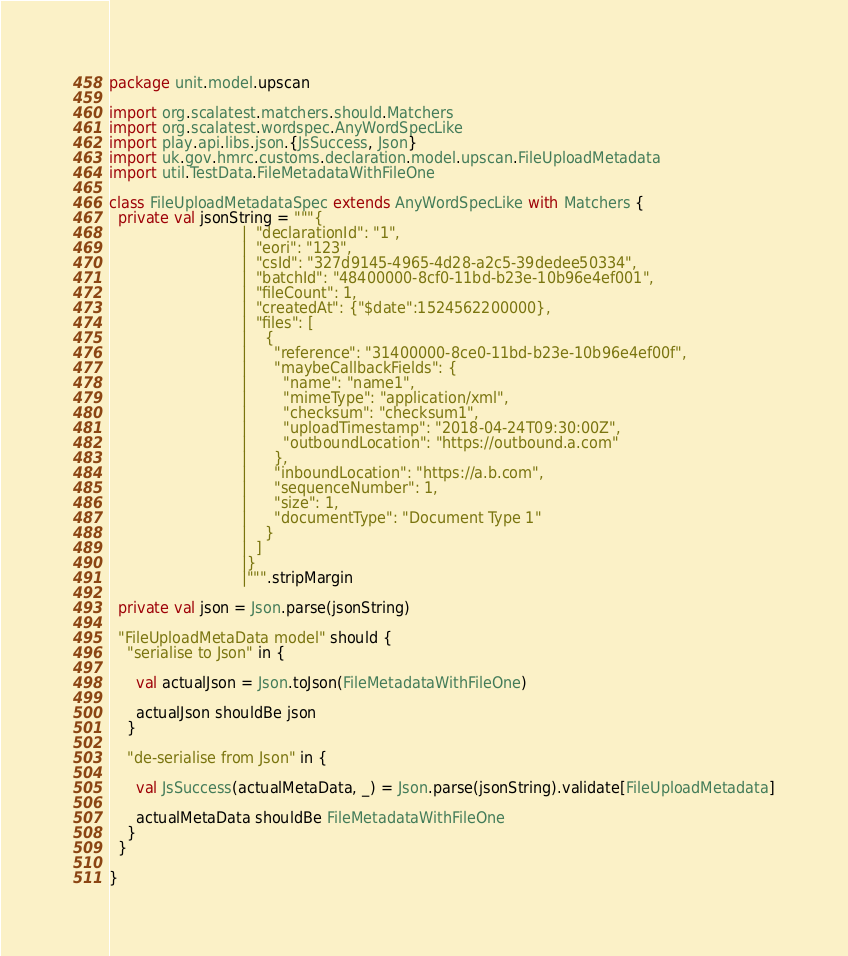Convert code to text. <code><loc_0><loc_0><loc_500><loc_500><_Scala_>
package unit.model.upscan

import org.scalatest.matchers.should.Matchers
import org.scalatest.wordspec.AnyWordSpecLike
import play.api.libs.json.{JsSuccess, Json}
import uk.gov.hmrc.customs.declaration.model.upscan.FileUploadMetadata
import util.TestData.FileMetadataWithFileOne

class FileUploadMetadataSpec extends AnyWordSpecLike with Matchers {
  private val jsonString = """{
                             |  "declarationId": "1",
                             |  "eori": "123",
                             |  "csId": "327d9145-4965-4d28-a2c5-39dedee50334",
                             |  "batchId": "48400000-8cf0-11bd-b23e-10b96e4ef001",
                             |  "fileCount": 1,
                             |  "createdAt": {"$date":1524562200000},
                             |  "files": [
                             |    {
                             |      "reference": "31400000-8ce0-11bd-b23e-10b96e4ef00f",
                             |      "maybeCallbackFields": {
                             |        "name": "name1",
                             |        "mimeType": "application/xml",
                             |        "checksum": "checksum1",
                             |        "uploadTimestamp": "2018-04-24T09:30:00Z",
                             |        "outboundLocation": "https://outbound.a.com"
                             |      },
                             |      "inboundLocation": "https://a.b.com",
                             |      "sequenceNumber": 1,
                             |      "size": 1,
                             |      "documentType": "Document Type 1"
                             |    }
                             |  ]
                             |}
                             |""".stripMargin

  private val json = Json.parse(jsonString)

  "FileUploadMetaData model" should {
    "serialise to Json" in {

      val actualJson = Json.toJson(FileMetadataWithFileOne)

      actualJson shouldBe json
    }

    "de-serialise from Json" in {

      val JsSuccess(actualMetaData, _) = Json.parse(jsonString).validate[FileUploadMetadata]

      actualMetaData shouldBe FileMetadataWithFileOne
    }
  }

}
</code> 